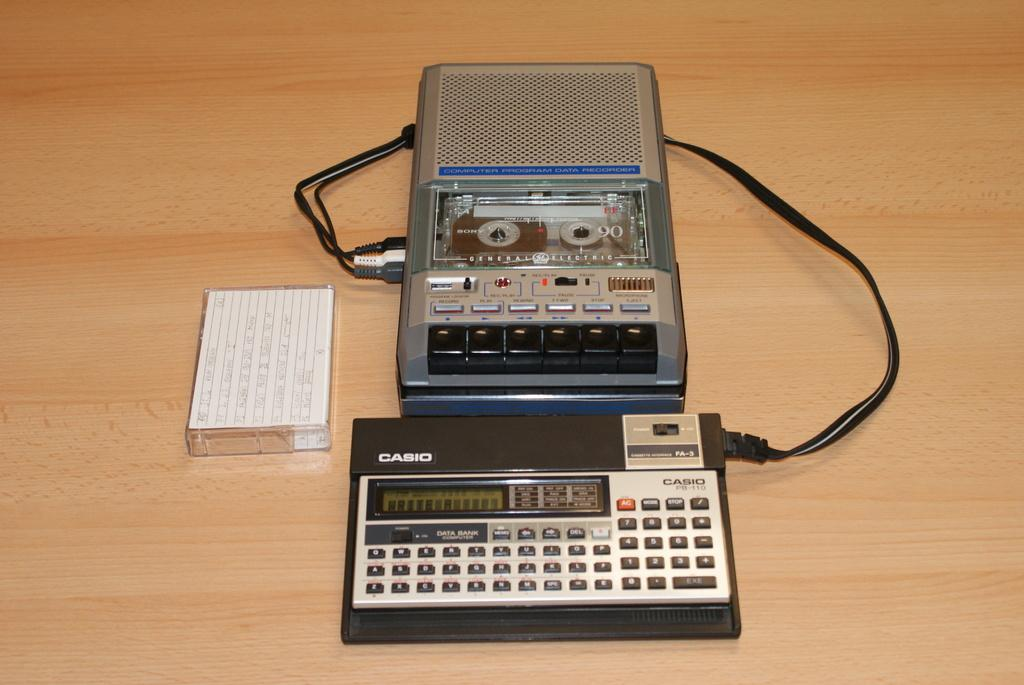Provide a one-sentence caption for the provided image. A tape recorder is hooked into a small Casio keyboard. 